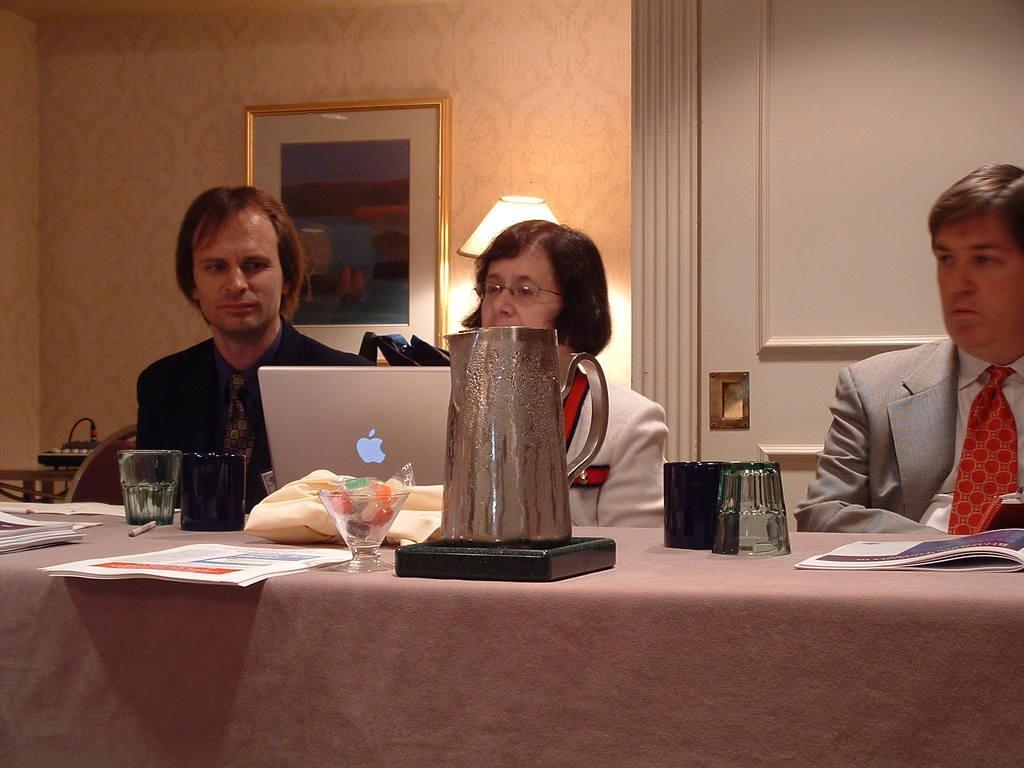How would you summarize this image in a sentence or two? There is a woman sitting at the center. There is a man who is sitting at right side. There is another person who is sitting left side of a woman. This is a laptop. This is a glass. This is a water jar. There is a photo frame onto the wall and this is a table lamp. 